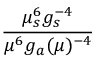<formula> <loc_0><loc_0><loc_500><loc_500>{ \frac { \mu _ { s } ^ { 6 } g _ { s } ^ { - 4 } } { \mu ^ { 6 } g _ { a } ( \mu ) ^ { - 4 } } }</formula> 